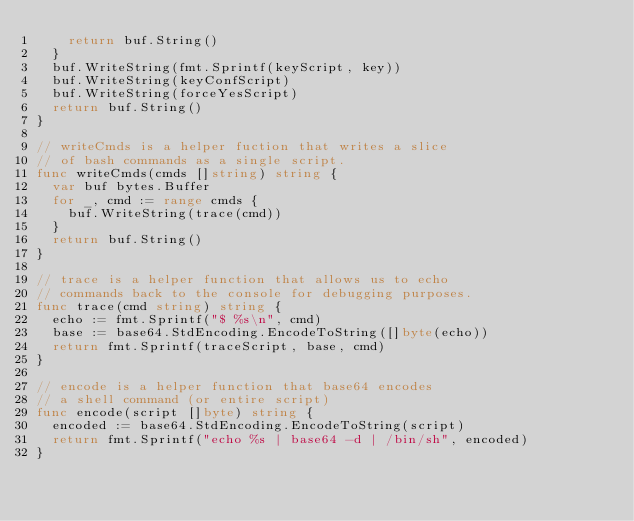Convert code to text. <code><loc_0><loc_0><loc_500><loc_500><_Go_>		return buf.String()
	}
	buf.WriteString(fmt.Sprintf(keyScript, key))
	buf.WriteString(keyConfScript)
	buf.WriteString(forceYesScript)
	return buf.String()
}

// writeCmds is a helper fuction that writes a slice
// of bash commands as a single script.
func writeCmds(cmds []string) string {
	var buf bytes.Buffer
	for _, cmd := range cmds {
		buf.WriteString(trace(cmd))
	}
	return buf.String()
}

// trace is a helper function that allows us to echo
// commands back to the console for debugging purposes.
func trace(cmd string) string {
	echo := fmt.Sprintf("$ %s\n", cmd)
	base := base64.StdEncoding.EncodeToString([]byte(echo))
	return fmt.Sprintf(traceScript, base, cmd)
}

// encode is a helper function that base64 encodes
// a shell command (or entire script)
func encode(script []byte) string {
	encoded := base64.StdEncoding.EncodeToString(script)
	return fmt.Sprintf("echo %s | base64 -d | /bin/sh", encoded)
}
</code> 